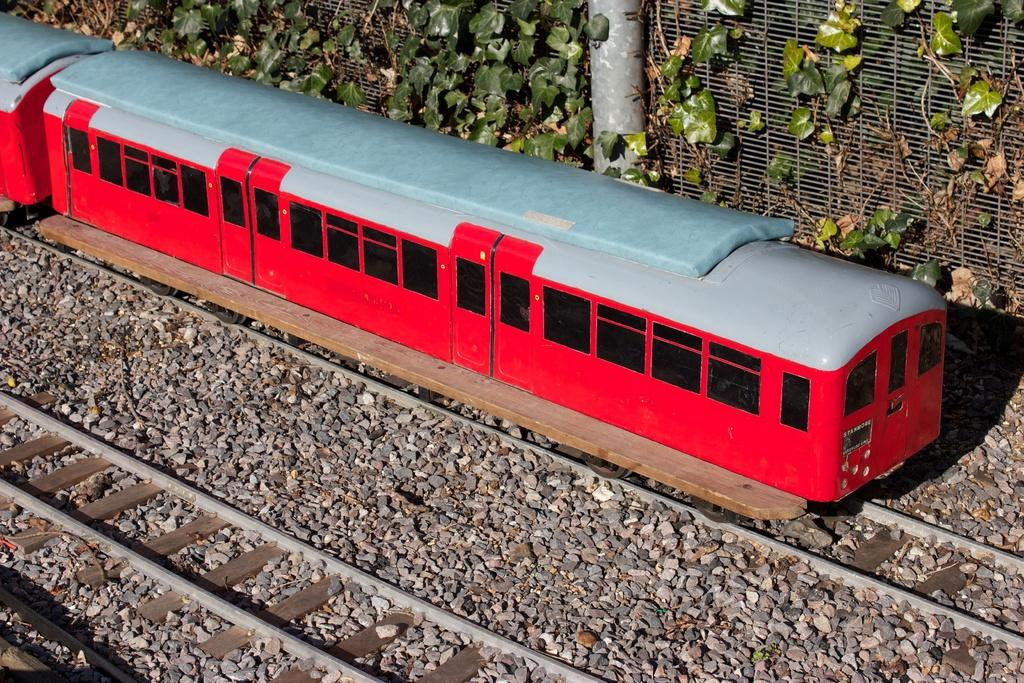What type of toys can be seen in the image? There is a toys set in the image. What is included in the toys set? The toys set includes tracks and a train. What type of barrier is present in the toys set? There is fencing in the toys set. What other elements can be seen in the image? There are plants and stones visible in the image. What type of wire is used to hold the milk in the image? There is no wire or milk present in the image. What things are being used to create the toys set in the image? The toys set in the image consists of tracks, a train, and fencing, as mentioned in the provided facts. 